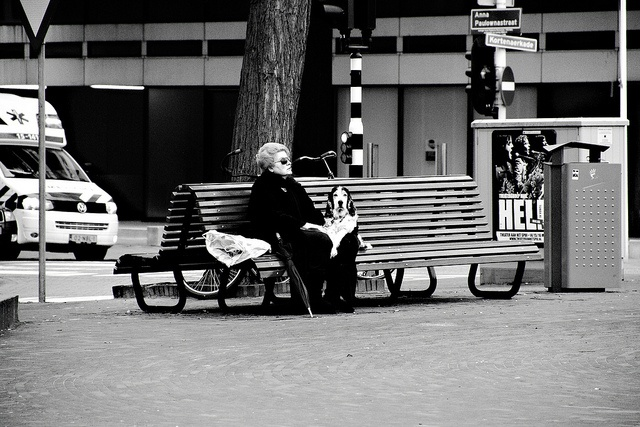Describe the objects in this image and their specific colors. I can see bench in black, lightgray, darkgray, and gray tones, truck in black, white, darkgray, and gray tones, people in black, lightgray, darkgray, and gray tones, bench in black, darkgray, gray, and lightgray tones, and dog in black, white, darkgray, and gray tones in this image. 